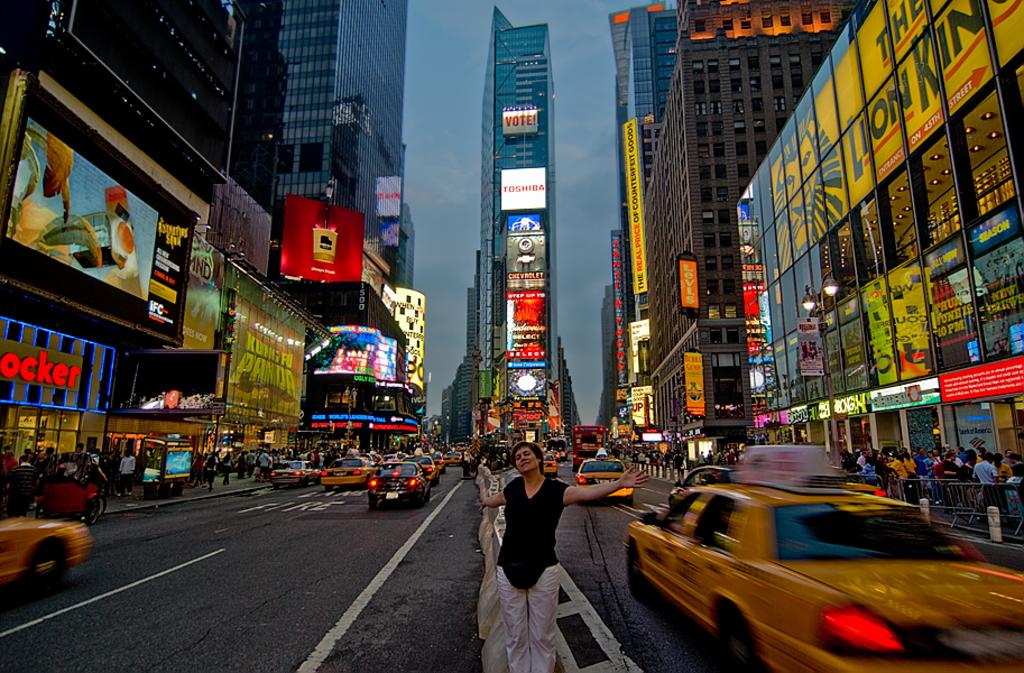Provide a one-sentence caption for the provided image. A busy street has a banner on yellow advertising the Lion King.. 